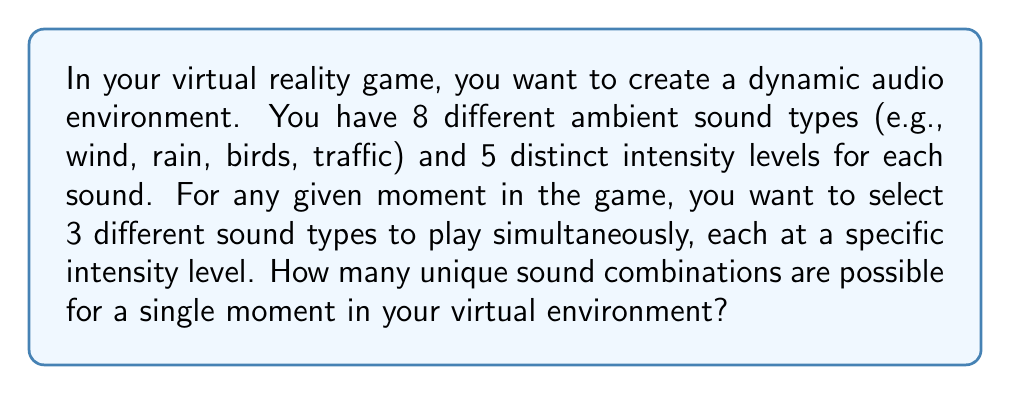Give your solution to this math problem. Let's break this problem down step-by-step:

1) First, we need to choose 3 sound types out of the 8 available. This is a combination problem, as the order doesn't matter. We can calculate this using the combination formula:

   $$\binom{8}{3} = \frac{8!}{3!(8-3)!} = \frac{8!}{3!5!} = 56$$

2) For each of these 3 chosen sound types, we need to select an intensity level out of 5 possible levels. This is an independent choice for each sound, so we multiply the number of choices:

   $$5 \times 5 \times 5 = 5^3 = 125$$

3) Now, for each way of choosing 3 sound types, we have 125 ways to assign intensity levels. Therefore, we multiply these together:

   $$56 \times 125 = 7,000$$

This calculation follows the multiplication principle of counting. We're multiplying the number of ways to choose the sounds by the number of ways to assign intensities to each chosen sound.
Answer: There are 7,000 unique sound combinations possible for a single moment in the virtual environment. 